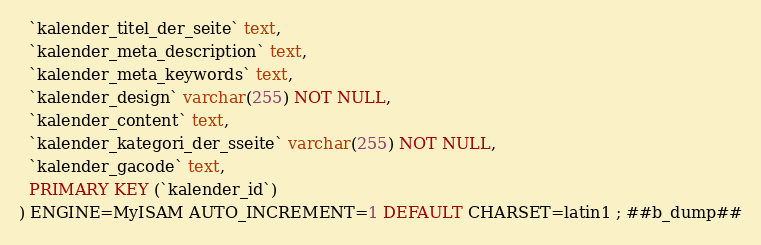<code> <loc_0><loc_0><loc_500><loc_500><_SQL_>  `kalender_titel_der_seite` text,
  `kalender_meta_description` text,
  `kalender_meta_keywords` text,
  `kalender_design` varchar(255) NOT NULL,
  `kalender_content` text,
  `kalender_kategori_der_sseite` varchar(255) NOT NULL,
  `kalender_gacode` text,
  PRIMARY KEY (`kalender_id`)
) ENGINE=MyISAM AUTO_INCREMENT=1 DEFAULT CHARSET=latin1 ; ##b_dump##
</code> 